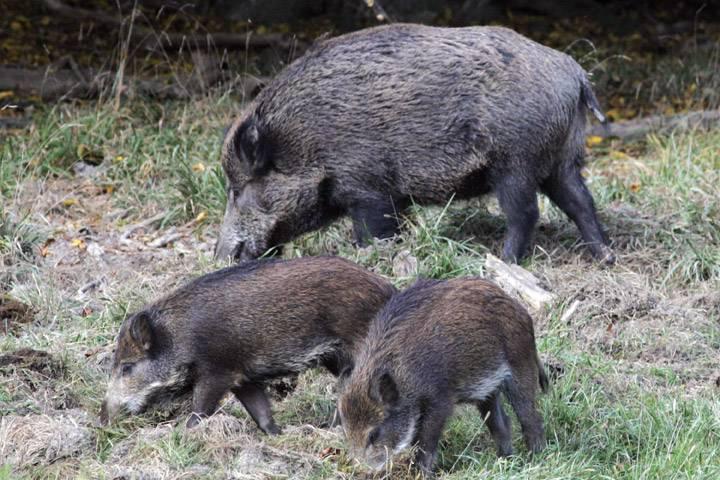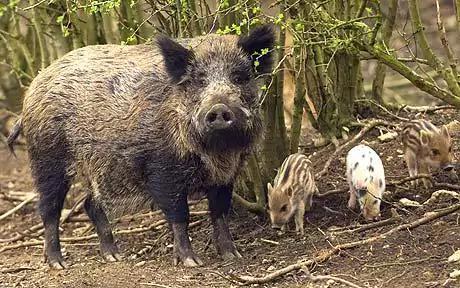The first image is the image on the left, the second image is the image on the right. For the images displayed, is the sentence "One of the images has at least one person posing over a dead animal on snowy ground." factually correct? Answer yes or no. No. The first image is the image on the left, the second image is the image on the right. Evaluate the accuracy of this statement regarding the images: "A man is holding a gun horizontally.". Is it true? Answer yes or no. No. 